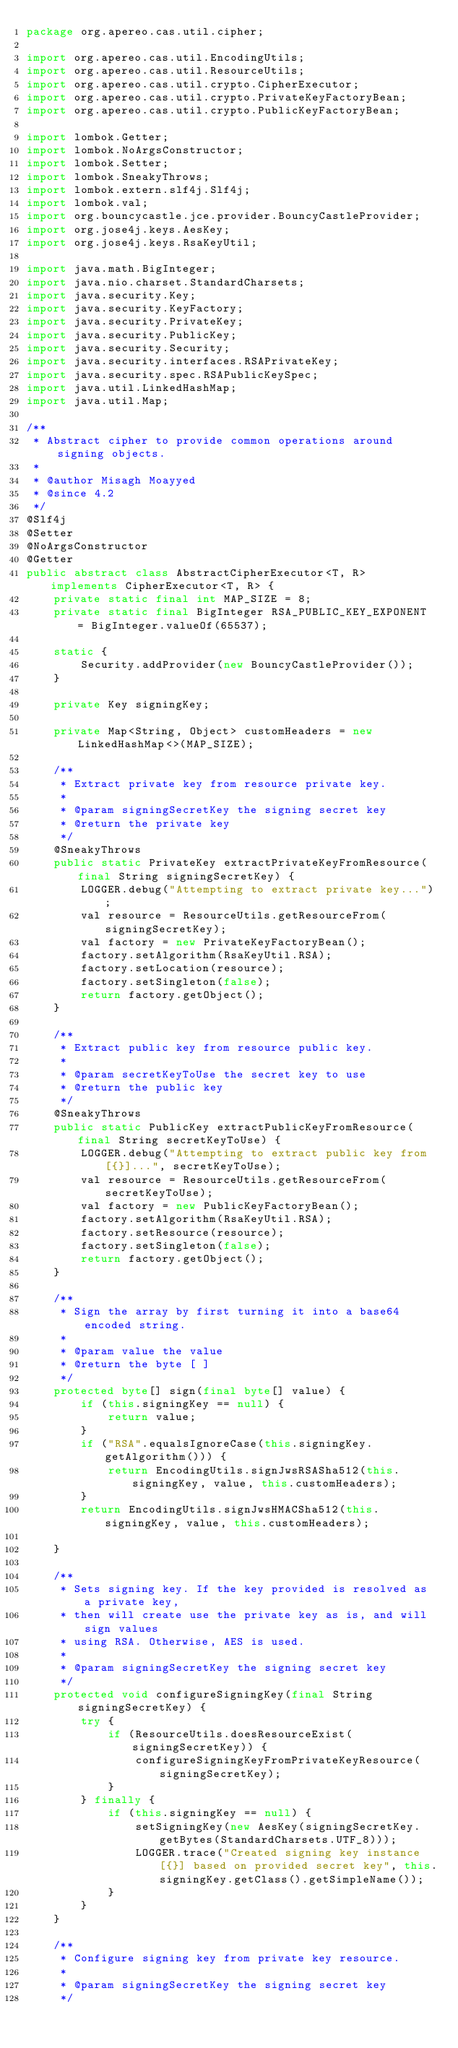Convert code to text. <code><loc_0><loc_0><loc_500><loc_500><_Java_>package org.apereo.cas.util.cipher;

import org.apereo.cas.util.EncodingUtils;
import org.apereo.cas.util.ResourceUtils;
import org.apereo.cas.util.crypto.CipherExecutor;
import org.apereo.cas.util.crypto.PrivateKeyFactoryBean;
import org.apereo.cas.util.crypto.PublicKeyFactoryBean;

import lombok.Getter;
import lombok.NoArgsConstructor;
import lombok.Setter;
import lombok.SneakyThrows;
import lombok.extern.slf4j.Slf4j;
import lombok.val;
import org.bouncycastle.jce.provider.BouncyCastleProvider;
import org.jose4j.keys.AesKey;
import org.jose4j.keys.RsaKeyUtil;

import java.math.BigInteger;
import java.nio.charset.StandardCharsets;
import java.security.Key;
import java.security.KeyFactory;
import java.security.PrivateKey;
import java.security.PublicKey;
import java.security.Security;
import java.security.interfaces.RSAPrivateKey;
import java.security.spec.RSAPublicKeySpec;
import java.util.LinkedHashMap;
import java.util.Map;

/**
 * Abstract cipher to provide common operations around signing objects.
 *
 * @author Misagh Moayyed
 * @since 4.2
 */
@Slf4j
@Setter
@NoArgsConstructor
@Getter
public abstract class AbstractCipherExecutor<T, R> implements CipherExecutor<T, R> {
    private static final int MAP_SIZE = 8;
    private static final BigInteger RSA_PUBLIC_KEY_EXPONENT = BigInteger.valueOf(65537);

    static {
        Security.addProvider(new BouncyCastleProvider());
    }
    
    private Key signingKey;

    private Map<String, Object> customHeaders = new LinkedHashMap<>(MAP_SIZE);
    
    /**
     * Extract private key from resource private key.
     *
     * @param signingSecretKey the signing secret key
     * @return the private key
     */
    @SneakyThrows
    public static PrivateKey extractPrivateKeyFromResource(final String signingSecretKey) {
        LOGGER.debug("Attempting to extract private key...");
        val resource = ResourceUtils.getResourceFrom(signingSecretKey);
        val factory = new PrivateKeyFactoryBean();
        factory.setAlgorithm(RsaKeyUtil.RSA);
        factory.setLocation(resource);
        factory.setSingleton(false);
        return factory.getObject();
    }

    /**
     * Extract public key from resource public key.
     *
     * @param secretKeyToUse the secret key to use
     * @return the public key
     */
    @SneakyThrows
    public static PublicKey extractPublicKeyFromResource(final String secretKeyToUse) {
        LOGGER.debug("Attempting to extract public key from [{}]...", secretKeyToUse);
        val resource = ResourceUtils.getResourceFrom(secretKeyToUse);
        val factory = new PublicKeyFactoryBean();
        factory.setAlgorithm(RsaKeyUtil.RSA);
        factory.setResource(resource);
        factory.setSingleton(false);
        return factory.getObject();
    }

    /**
     * Sign the array by first turning it into a base64 encoded string.
     *
     * @param value the value
     * @return the byte [ ]
     */
    protected byte[] sign(final byte[] value) {
        if (this.signingKey == null) {
            return value;
        }
        if ("RSA".equalsIgnoreCase(this.signingKey.getAlgorithm())) {
            return EncodingUtils.signJwsRSASha512(this.signingKey, value, this.customHeaders);
        }
        return EncodingUtils.signJwsHMACSha512(this.signingKey, value, this.customHeaders);

    }

    /**
     * Sets signing key. If the key provided is resolved as a private key,
     * then will create use the private key as is, and will sign values
     * using RSA. Otherwise, AES is used.
     *
     * @param signingSecretKey the signing secret key
     */
    protected void configureSigningKey(final String signingSecretKey) {
        try {
            if (ResourceUtils.doesResourceExist(signingSecretKey)) {
                configureSigningKeyFromPrivateKeyResource(signingSecretKey);
            }
        } finally {
            if (this.signingKey == null) {
                setSigningKey(new AesKey(signingSecretKey.getBytes(StandardCharsets.UTF_8)));
                LOGGER.trace("Created signing key instance [{}] based on provided secret key", this.signingKey.getClass().getSimpleName());
            }
        }
    }

    /**
     * Configure signing key from private key resource.
     *
     * @param signingSecretKey the signing secret key
     */</code> 